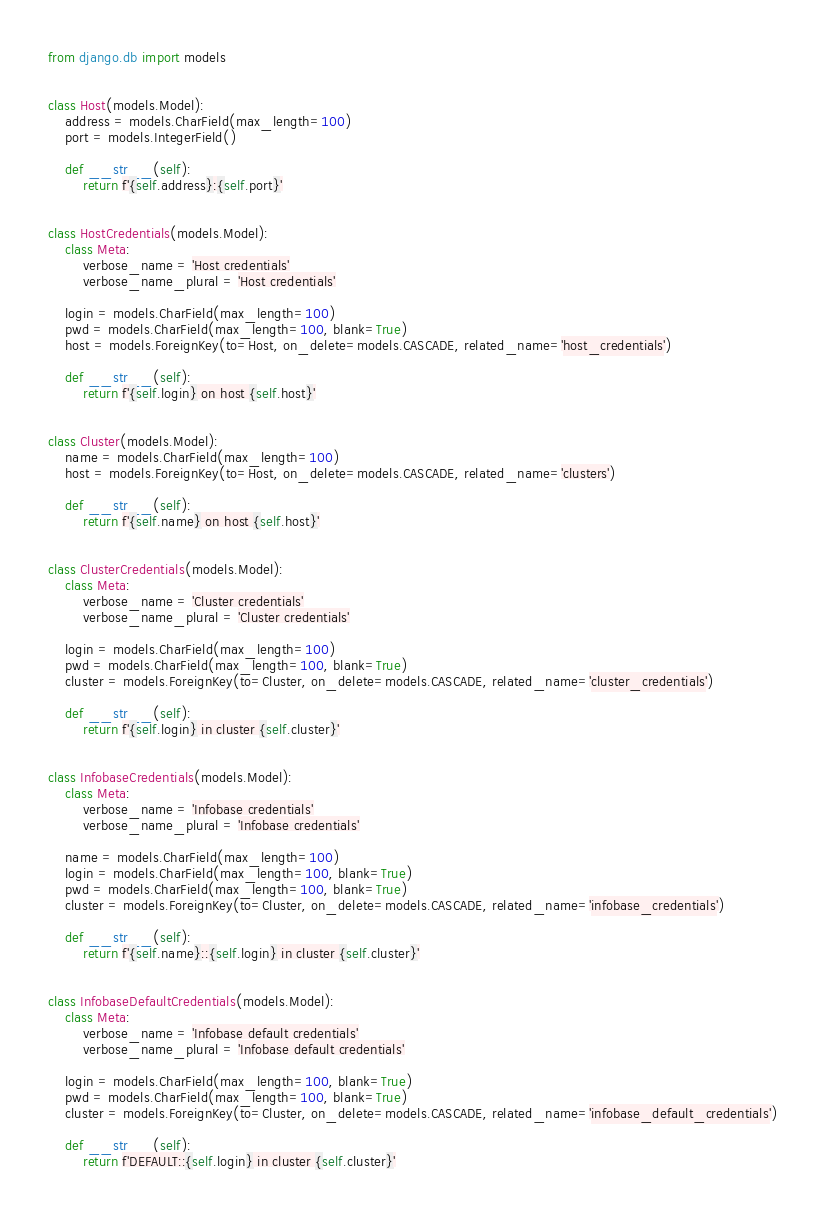Convert code to text. <code><loc_0><loc_0><loc_500><loc_500><_Python_>from django.db import models


class Host(models.Model):
    address = models.CharField(max_length=100)
    port = models.IntegerField()

    def __str__(self):
        return f'{self.address}:{self.port}'


class HostCredentials(models.Model):
    class Meta:
        verbose_name = 'Host credentials'
        verbose_name_plural = 'Host credentials'

    login = models.CharField(max_length=100)
    pwd = models.CharField(max_length=100, blank=True)
    host = models.ForeignKey(to=Host, on_delete=models.CASCADE, related_name='host_credentials')

    def __str__(self):
        return f'{self.login} on host {self.host}'


class Cluster(models.Model):
    name = models.CharField(max_length=100)
    host = models.ForeignKey(to=Host, on_delete=models.CASCADE, related_name='clusters')

    def __str__(self):
        return f'{self.name} on host {self.host}'


class ClusterCredentials(models.Model):
    class Meta:
        verbose_name = 'Cluster credentials'
        verbose_name_plural = 'Cluster credentials'

    login = models.CharField(max_length=100)
    pwd = models.CharField(max_length=100, blank=True)
    cluster = models.ForeignKey(to=Cluster, on_delete=models.CASCADE, related_name='cluster_credentials')

    def __str__(self):
        return f'{self.login} in cluster {self.cluster}'


class InfobaseCredentials(models.Model):
    class Meta:
        verbose_name = 'Infobase credentials'
        verbose_name_plural = 'Infobase credentials'

    name = models.CharField(max_length=100)
    login = models.CharField(max_length=100, blank=True)
    pwd = models.CharField(max_length=100, blank=True)
    cluster = models.ForeignKey(to=Cluster, on_delete=models.CASCADE, related_name='infobase_credentials')

    def __str__(self):
        return f'{self.name}::{self.login} in cluster {self.cluster}'


class InfobaseDefaultCredentials(models.Model):
    class Meta:
        verbose_name = 'Infobase default credentials'
        verbose_name_plural = 'Infobase default credentials'

    login = models.CharField(max_length=100, blank=True)
    pwd = models.CharField(max_length=100, blank=True)
    cluster = models.ForeignKey(to=Cluster, on_delete=models.CASCADE, related_name='infobase_default_credentials')

    def __str__(self):
        return f'DEFAULT::{self.login} in cluster {self.cluster}'
</code> 